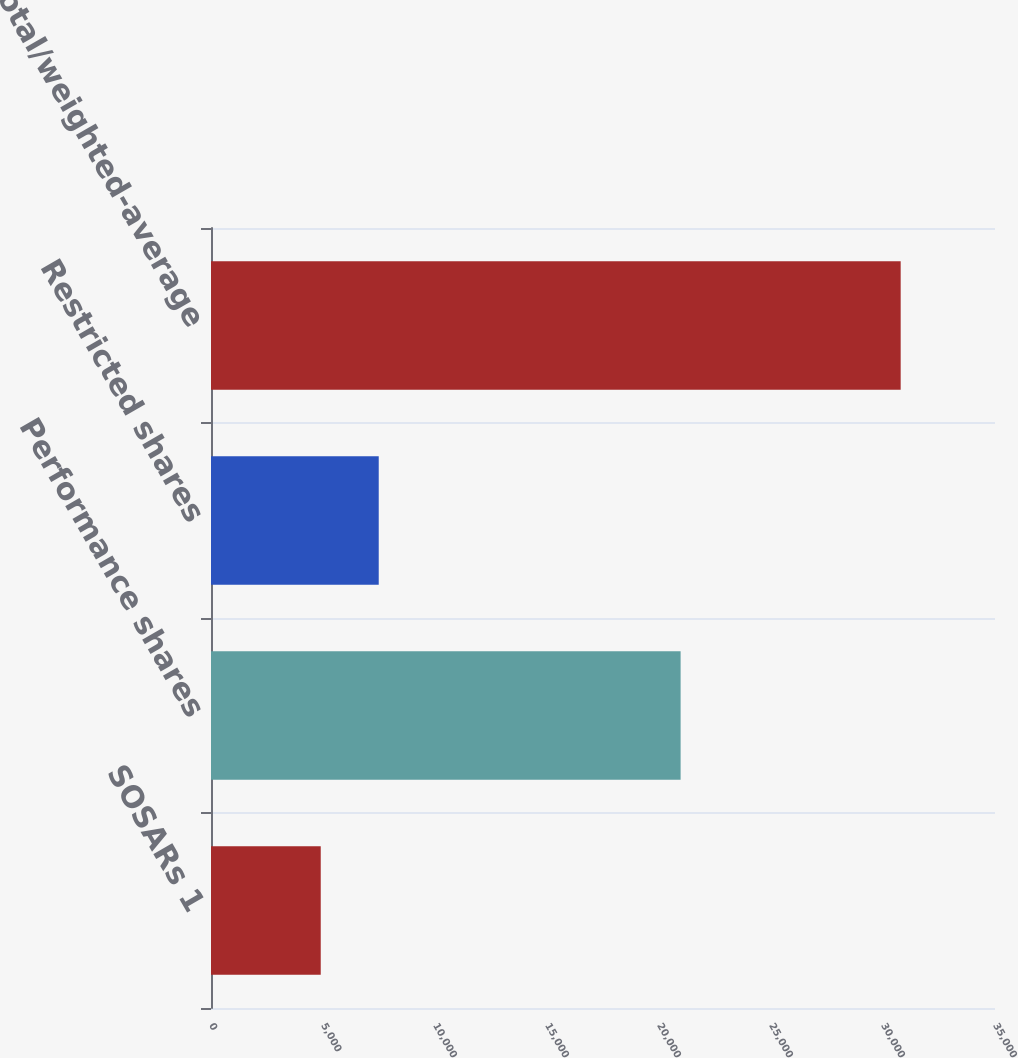<chart> <loc_0><loc_0><loc_500><loc_500><bar_chart><fcel>SOSARs 1<fcel>Performance shares<fcel>Restricted shares<fcel>Total/weighted-average<nl><fcel>4899<fcel>20965<fcel>7488<fcel>30789<nl></chart> 